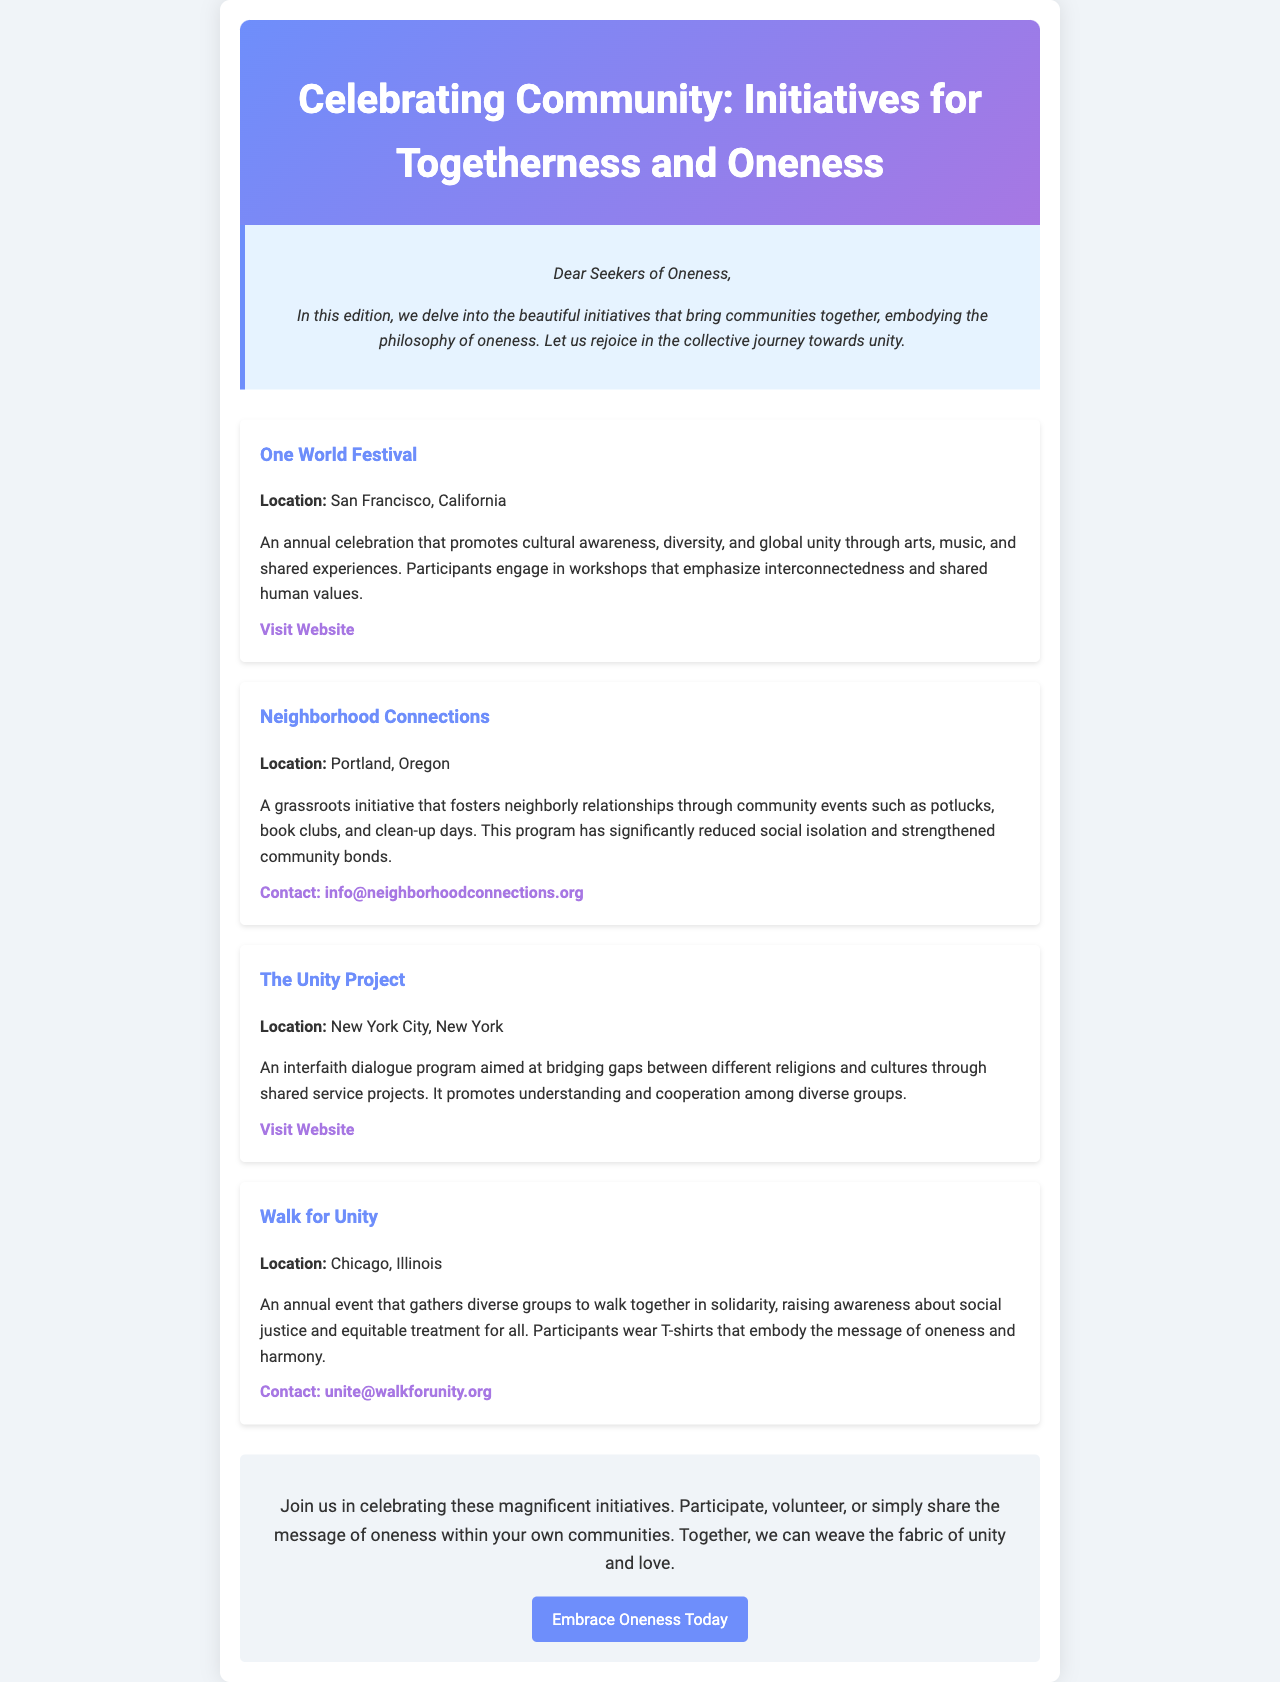What is the title of the newsletter? The title of the newsletter is prominently displayed at the top of the document.
Answer: Celebrating Community: Initiatives for Togetherness and Oneness Where is the One World Festival located? The location of the One World Festival is mentioned in the initiative description.
Answer: San Francisco, California What initiative aims to reduce social isolation? The initiative that focuses on reducing social isolation is described in the newsletter.
Answer: Neighborhood Connections How many initiatives are highlighted in the newsletter? The number of initiatives is determined by counting the individual sections in the document.
Answer: Four What is the main theme of the initiatives mentioned? The theme can be inferred from the title and descriptions throughout the document.
Answer: Togetherness and oneness Which initiative focuses on interfaith dialogue? The initiative that is dedicated to interfaith dialogue is labeled in the document.
Answer: The Unity Project What type of event is the Walk for Unity? The type of event is specified in the description of that initiative in the newsletter.
Answer: Annual event What is the call to action at the end of the newsletter? The call to action is presented in the concluding section of the document.
Answer: Embrace Oneness Today 